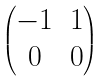<formula> <loc_0><loc_0><loc_500><loc_500>\begin{pmatrix} - 1 & 1 \\ 0 & 0 \end{pmatrix}</formula> 